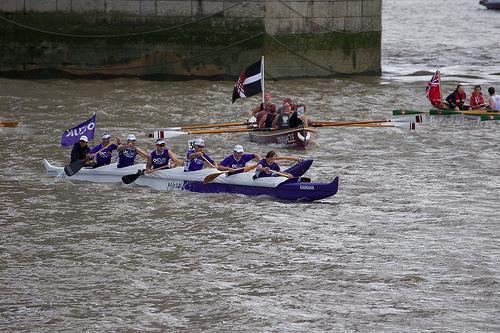How many boats are visible?
Give a very brief answer. 3. 